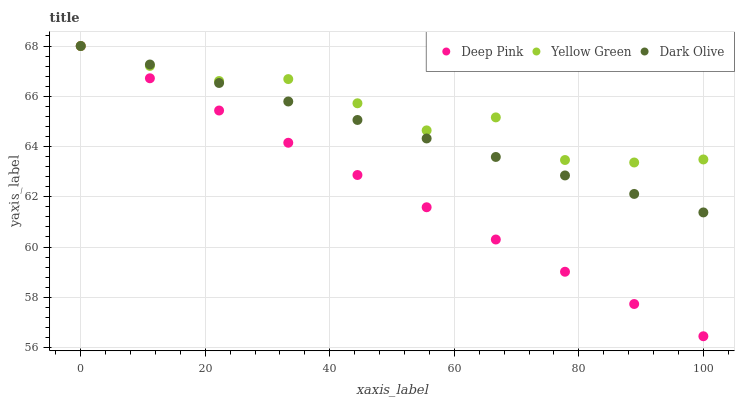Does Deep Pink have the minimum area under the curve?
Answer yes or no. Yes. Does Yellow Green have the maximum area under the curve?
Answer yes or no. Yes. Does Yellow Green have the minimum area under the curve?
Answer yes or no. No. Does Deep Pink have the maximum area under the curve?
Answer yes or no. No. Is Deep Pink the smoothest?
Answer yes or no. Yes. Is Yellow Green the roughest?
Answer yes or no. Yes. Is Yellow Green the smoothest?
Answer yes or no. No. Is Deep Pink the roughest?
Answer yes or no. No. Does Deep Pink have the lowest value?
Answer yes or no. Yes. Does Yellow Green have the lowest value?
Answer yes or no. No. Does Yellow Green have the highest value?
Answer yes or no. Yes. Does Dark Olive intersect Deep Pink?
Answer yes or no. Yes. Is Dark Olive less than Deep Pink?
Answer yes or no. No. Is Dark Olive greater than Deep Pink?
Answer yes or no. No. 